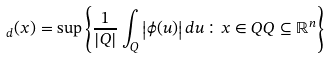Convert formula to latex. <formula><loc_0><loc_0><loc_500><loc_500>\, _ { d } ( x ) = \sup \left \{ \frac { 1 } { \left | Q \right | } \int _ { Q } \left | \phi ( u ) \right | d u \colon x \in Q Q \subseteq \mathbb { R } ^ { n } \right \}</formula> 